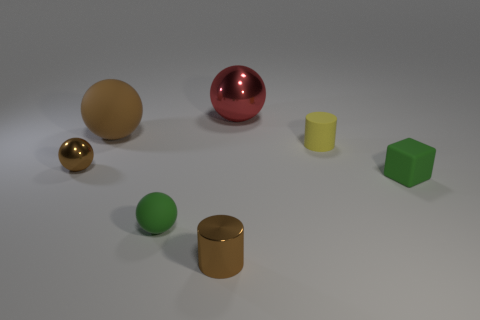Is the yellow rubber thing the same shape as the large brown object?
Provide a short and direct response. No. What is the size of the cylinder that is made of the same material as the red thing?
Your response must be concise. Small. Is the color of the large rubber object the same as the small shiny ball?
Provide a succinct answer. Yes. There is a tiny object that is behind the small cube and left of the yellow thing; what is its material?
Make the answer very short. Metal. What is the size of the brown thing that is the same shape as the tiny yellow rubber thing?
Keep it short and to the point. Small. What is the material of the cylinder that is to the right of the metallic sphere right of the small brown cylinder that is in front of the large red metal ball?
Provide a succinct answer. Rubber. What is the size of the cylinder that is in front of the yellow matte thing on the right side of the large brown object?
Your answer should be very brief. Small. The other matte object that is the same shape as the big rubber thing is what color?
Offer a very short reply. Green. What number of tiny shiny objects have the same color as the small matte block?
Ensure brevity in your answer.  0. Is the size of the rubber cube the same as the brown matte ball?
Ensure brevity in your answer.  No. 